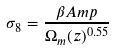<formula> <loc_0><loc_0><loc_500><loc_500>\sigma _ { 8 } = \frac { \beta A m p } { \Omega _ { m } ( z ) ^ { 0 . 5 5 } }</formula> 